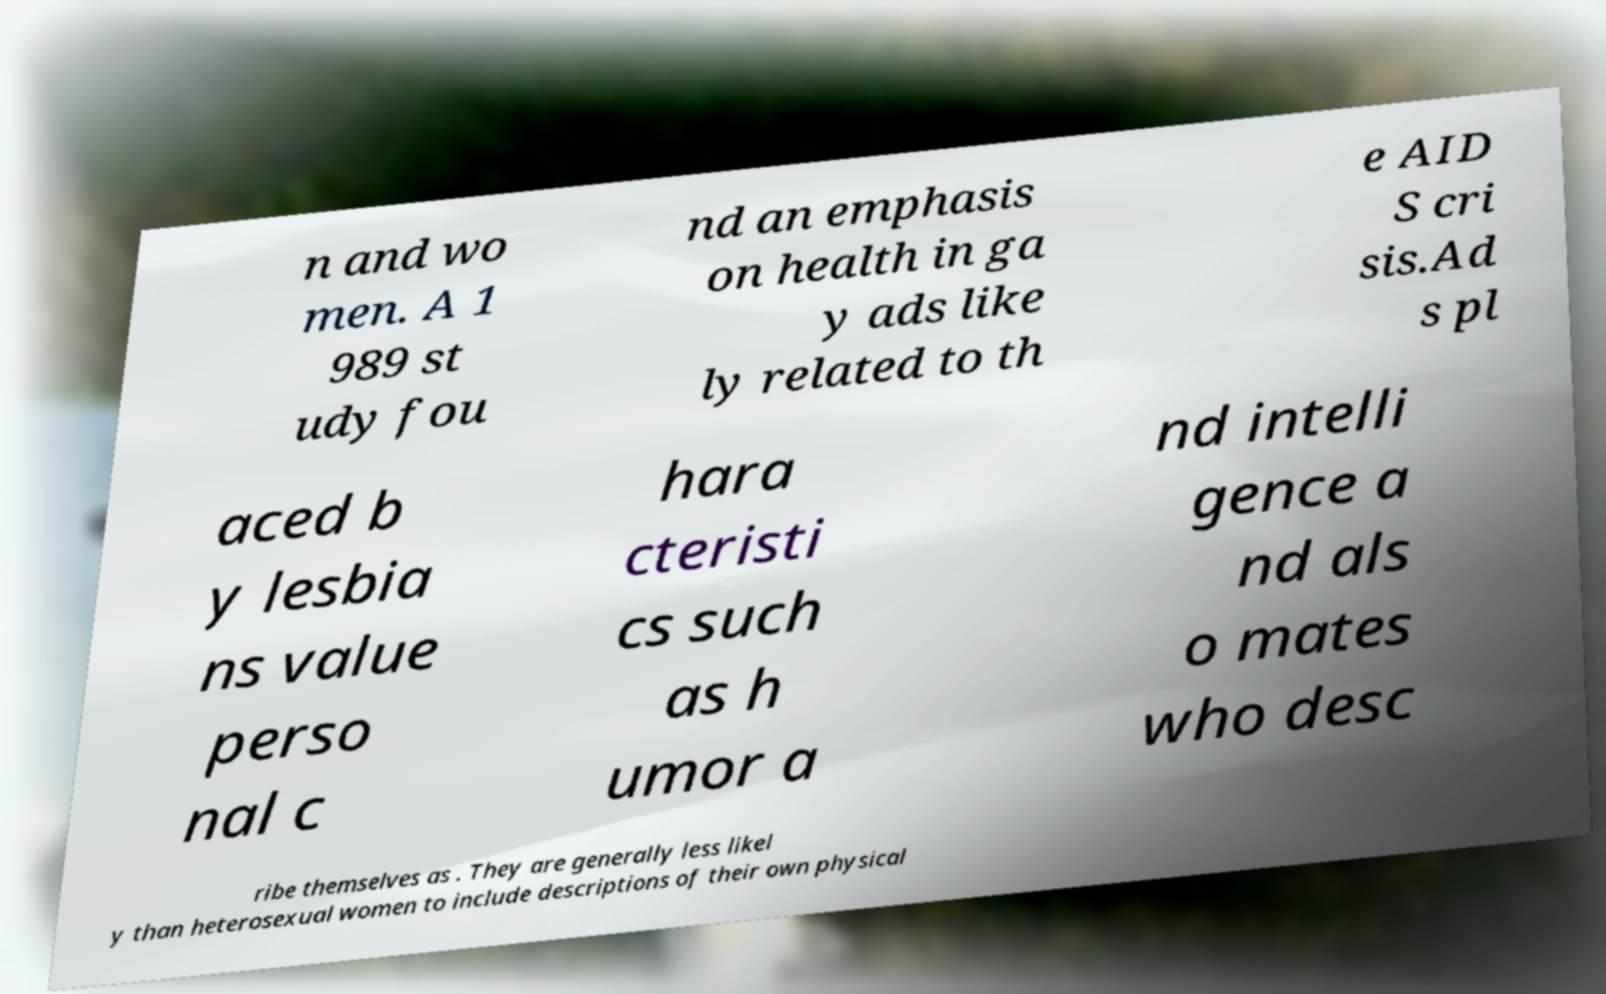Can you accurately transcribe the text from the provided image for me? n and wo men. A 1 989 st udy fou nd an emphasis on health in ga y ads like ly related to th e AID S cri sis.Ad s pl aced b y lesbia ns value perso nal c hara cteristi cs such as h umor a nd intelli gence a nd als o mates who desc ribe themselves as . They are generally less likel y than heterosexual women to include descriptions of their own physical 